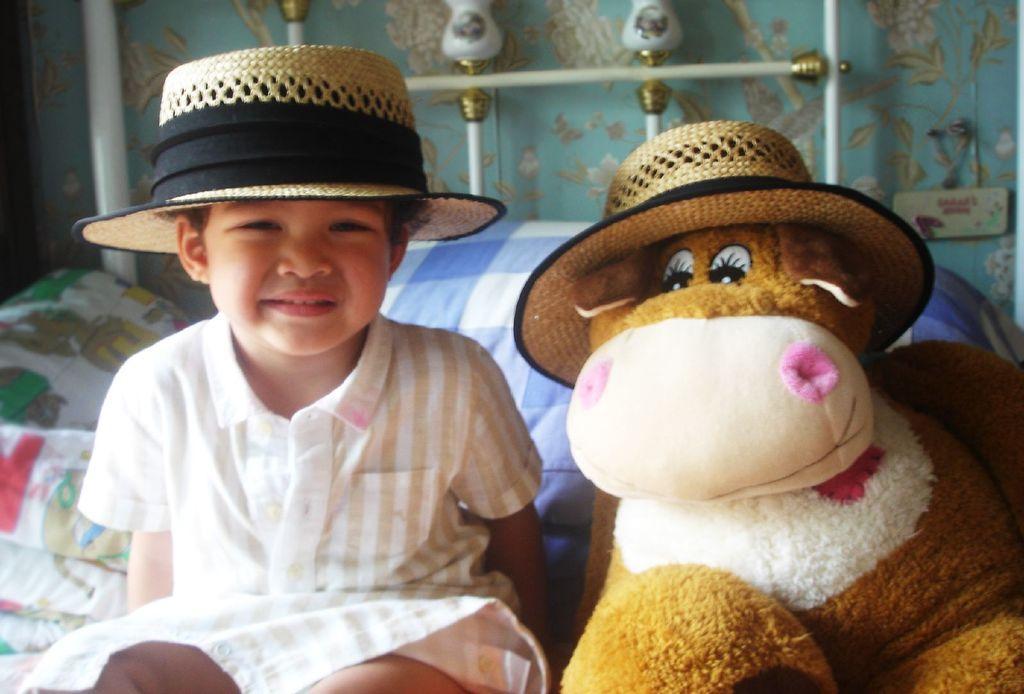In one or two sentences, can you explain what this image depicts? This picture is taken inside the room. In this image, on the left side, we can see a kid wearing a hat is sitting on the bed. On the right side, we can also see a toy. In the background, we can see a bed, metal rod and a wall which is in blue color. 